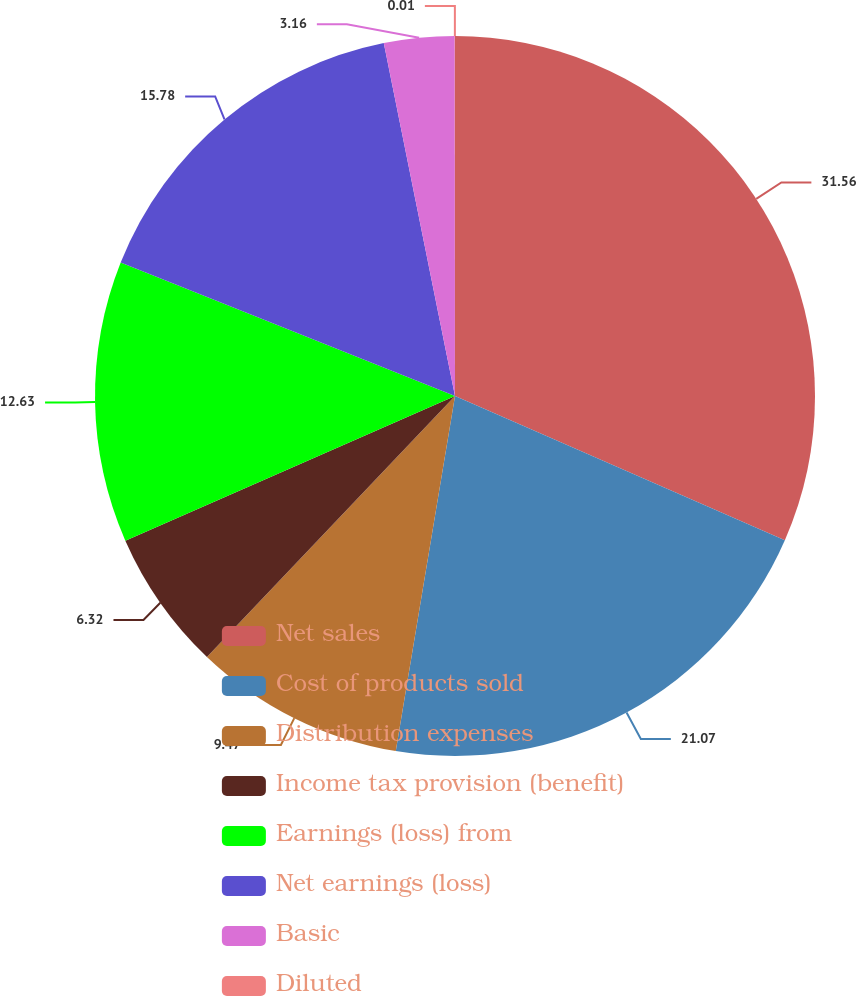Convert chart. <chart><loc_0><loc_0><loc_500><loc_500><pie_chart><fcel>Net sales<fcel>Cost of products sold<fcel>Distribution expenses<fcel>Income tax provision (benefit)<fcel>Earnings (loss) from<fcel>Net earnings (loss)<fcel>Basic<fcel>Diluted<nl><fcel>31.56%<fcel>21.07%<fcel>9.47%<fcel>6.32%<fcel>12.63%<fcel>15.78%<fcel>3.16%<fcel>0.01%<nl></chart> 